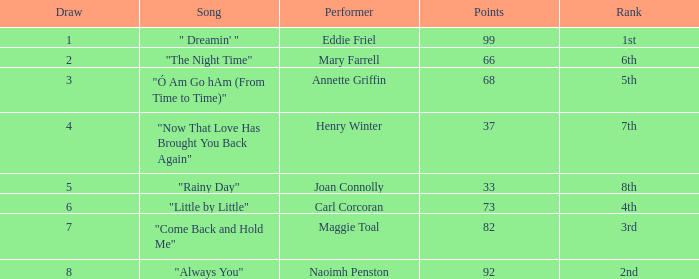Which song has more than 66 points, a draw greater than 3, and is ranked 3rd? "Come Back and Hold Me". 